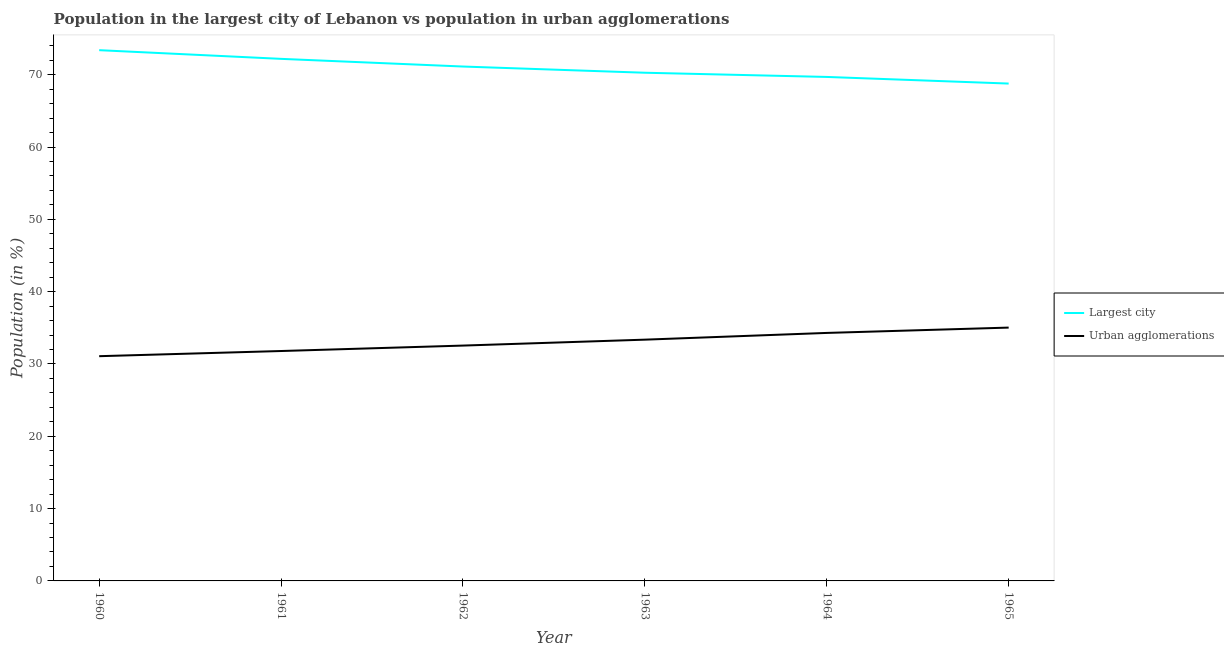Does the line corresponding to population in urban agglomerations intersect with the line corresponding to population in the largest city?
Keep it short and to the point. No. What is the population in urban agglomerations in 1964?
Provide a succinct answer. 34.29. Across all years, what is the maximum population in urban agglomerations?
Ensure brevity in your answer.  35.03. Across all years, what is the minimum population in the largest city?
Provide a succinct answer. 68.77. In which year was the population in urban agglomerations maximum?
Your answer should be very brief. 1965. In which year was the population in urban agglomerations minimum?
Your answer should be very brief. 1960. What is the total population in the largest city in the graph?
Offer a terse response. 425.45. What is the difference between the population in urban agglomerations in 1961 and that in 1965?
Provide a short and direct response. -3.24. What is the difference between the population in the largest city in 1964 and the population in urban agglomerations in 1962?
Provide a succinct answer. 37.15. What is the average population in the largest city per year?
Make the answer very short. 70.91. In the year 1965, what is the difference between the population in urban agglomerations and population in the largest city?
Offer a very short reply. -33.74. In how many years, is the population in urban agglomerations greater than 50 %?
Ensure brevity in your answer.  0. What is the ratio of the population in the largest city in 1961 to that in 1962?
Give a very brief answer. 1.01. Is the population in urban agglomerations in 1961 less than that in 1962?
Offer a very short reply. Yes. Is the difference between the population in urban agglomerations in 1961 and 1962 greater than the difference between the population in the largest city in 1961 and 1962?
Provide a succinct answer. No. What is the difference between the highest and the second highest population in the largest city?
Your answer should be compact. 1.2. What is the difference between the highest and the lowest population in urban agglomerations?
Your answer should be compact. 3.95. In how many years, is the population in urban agglomerations greater than the average population in urban agglomerations taken over all years?
Make the answer very short. 3. Is the population in urban agglomerations strictly less than the population in the largest city over the years?
Give a very brief answer. Yes. What is the difference between two consecutive major ticks on the Y-axis?
Your answer should be very brief. 10. Does the graph contain any zero values?
Provide a short and direct response. No. Does the graph contain grids?
Your response must be concise. No. Where does the legend appear in the graph?
Offer a very short reply. Center right. How many legend labels are there?
Make the answer very short. 2. How are the legend labels stacked?
Make the answer very short. Vertical. What is the title of the graph?
Provide a short and direct response. Population in the largest city of Lebanon vs population in urban agglomerations. Does "Domestic Liabilities" appear as one of the legend labels in the graph?
Offer a very short reply. No. What is the label or title of the Y-axis?
Ensure brevity in your answer.  Population (in %). What is the Population (in %) in Largest city in 1960?
Make the answer very short. 73.39. What is the Population (in %) in Urban agglomerations in 1960?
Give a very brief answer. 31.08. What is the Population (in %) of Largest city in 1961?
Give a very brief answer. 72.19. What is the Population (in %) in Urban agglomerations in 1961?
Make the answer very short. 31.79. What is the Population (in %) of Largest city in 1962?
Your answer should be very brief. 71.13. What is the Population (in %) of Urban agglomerations in 1962?
Your answer should be very brief. 32.54. What is the Population (in %) of Largest city in 1963?
Your answer should be very brief. 70.27. What is the Population (in %) of Urban agglomerations in 1963?
Your answer should be very brief. 33.36. What is the Population (in %) in Largest city in 1964?
Make the answer very short. 69.69. What is the Population (in %) of Urban agglomerations in 1964?
Give a very brief answer. 34.29. What is the Population (in %) of Largest city in 1965?
Provide a succinct answer. 68.77. What is the Population (in %) in Urban agglomerations in 1965?
Keep it short and to the point. 35.03. Across all years, what is the maximum Population (in %) of Largest city?
Offer a very short reply. 73.39. Across all years, what is the maximum Population (in %) of Urban agglomerations?
Your answer should be very brief. 35.03. Across all years, what is the minimum Population (in %) in Largest city?
Give a very brief answer. 68.77. Across all years, what is the minimum Population (in %) of Urban agglomerations?
Make the answer very short. 31.08. What is the total Population (in %) of Largest city in the graph?
Ensure brevity in your answer.  425.45. What is the total Population (in %) of Urban agglomerations in the graph?
Provide a short and direct response. 198.1. What is the difference between the Population (in %) in Largest city in 1960 and that in 1961?
Ensure brevity in your answer.  1.2. What is the difference between the Population (in %) of Urban agglomerations in 1960 and that in 1961?
Ensure brevity in your answer.  -0.72. What is the difference between the Population (in %) in Largest city in 1960 and that in 1962?
Offer a terse response. 2.26. What is the difference between the Population (in %) of Urban agglomerations in 1960 and that in 1962?
Make the answer very short. -1.47. What is the difference between the Population (in %) in Largest city in 1960 and that in 1963?
Provide a short and direct response. 3.12. What is the difference between the Population (in %) of Urban agglomerations in 1960 and that in 1963?
Offer a terse response. -2.29. What is the difference between the Population (in %) of Largest city in 1960 and that in 1964?
Keep it short and to the point. 3.7. What is the difference between the Population (in %) of Urban agglomerations in 1960 and that in 1964?
Offer a very short reply. -3.22. What is the difference between the Population (in %) in Largest city in 1960 and that in 1965?
Offer a very short reply. 4.62. What is the difference between the Population (in %) of Urban agglomerations in 1960 and that in 1965?
Provide a short and direct response. -3.95. What is the difference between the Population (in %) of Largest city in 1961 and that in 1962?
Your answer should be compact. 1.06. What is the difference between the Population (in %) in Urban agglomerations in 1961 and that in 1962?
Make the answer very short. -0.75. What is the difference between the Population (in %) of Largest city in 1961 and that in 1963?
Provide a succinct answer. 1.92. What is the difference between the Population (in %) of Urban agglomerations in 1961 and that in 1963?
Ensure brevity in your answer.  -1.57. What is the difference between the Population (in %) in Largest city in 1961 and that in 1964?
Your answer should be compact. 2.5. What is the difference between the Population (in %) of Urban agglomerations in 1961 and that in 1964?
Ensure brevity in your answer.  -2.5. What is the difference between the Population (in %) of Largest city in 1961 and that in 1965?
Make the answer very short. 3.42. What is the difference between the Population (in %) of Urban agglomerations in 1961 and that in 1965?
Your answer should be very brief. -3.24. What is the difference between the Population (in %) in Largest city in 1962 and that in 1963?
Provide a short and direct response. 0.86. What is the difference between the Population (in %) of Urban agglomerations in 1962 and that in 1963?
Give a very brief answer. -0.82. What is the difference between the Population (in %) of Largest city in 1962 and that in 1964?
Keep it short and to the point. 1.44. What is the difference between the Population (in %) in Urban agglomerations in 1962 and that in 1964?
Your answer should be compact. -1.75. What is the difference between the Population (in %) in Largest city in 1962 and that in 1965?
Provide a short and direct response. 2.36. What is the difference between the Population (in %) in Urban agglomerations in 1962 and that in 1965?
Offer a terse response. -2.49. What is the difference between the Population (in %) of Largest city in 1963 and that in 1964?
Your response must be concise. 0.58. What is the difference between the Population (in %) of Urban agglomerations in 1963 and that in 1964?
Your answer should be compact. -0.93. What is the difference between the Population (in %) in Largest city in 1963 and that in 1965?
Your response must be concise. 1.5. What is the difference between the Population (in %) of Urban agglomerations in 1963 and that in 1965?
Provide a succinct answer. -1.67. What is the difference between the Population (in %) in Largest city in 1964 and that in 1965?
Provide a succinct answer. 0.92. What is the difference between the Population (in %) in Urban agglomerations in 1964 and that in 1965?
Offer a very short reply. -0.74. What is the difference between the Population (in %) of Largest city in 1960 and the Population (in %) of Urban agglomerations in 1961?
Make the answer very short. 41.6. What is the difference between the Population (in %) in Largest city in 1960 and the Population (in %) in Urban agglomerations in 1962?
Make the answer very short. 40.85. What is the difference between the Population (in %) of Largest city in 1960 and the Population (in %) of Urban agglomerations in 1963?
Provide a short and direct response. 40.03. What is the difference between the Population (in %) in Largest city in 1960 and the Population (in %) in Urban agglomerations in 1964?
Offer a terse response. 39.1. What is the difference between the Population (in %) of Largest city in 1960 and the Population (in %) of Urban agglomerations in 1965?
Provide a short and direct response. 38.36. What is the difference between the Population (in %) in Largest city in 1961 and the Population (in %) in Urban agglomerations in 1962?
Your answer should be compact. 39.65. What is the difference between the Population (in %) in Largest city in 1961 and the Population (in %) in Urban agglomerations in 1963?
Keep it short and to the point. 38.83. What is the difference between the Population (in %) in Largest city in 1961 and the Population (in %) in Urban agglomerations in 1964?
Provide a short and direct response. 37.9. What is the difference between the Population (in %) in Largest city in 1961 and the Population (in %) in Urban agglomerations in 1965?
Ensure brevity in your answer.  37.16. What is the difference between the Population (in %) in Largest city in 1962 and the Population (in %) in Urban agglomerations in 1963?
Your answer should be very brief. 37.77. What is the difference between the Population (in %) in Largest city in 1962 and the Population (in %) in Urban agglomerations in 1964?
Provide a succinct answer. 36.84. What is the difference between the Population (in %) of Largest city in 1962 and the Population (in %) of Urban agglomerations in 1965?
Your answer should be very brief. 36.1. What is the difference between the Population (in %) of Largest city in 1963 and the Population (in %) of Urban agglomerations in 1964?
Give a very brief answer. 35.98. What is the difference between the Population (in %) of Largest city in 1963 and the Population (in %) of Urban agglomerations in 1965?
Ensure brevity in your answer.  35.24. What is the difference between the Population (in %) in Largest city in 1964 and the Population (in %) in Urban agglomerations in 1965?
Keep it short and to the point. 34.66. What is the average Population (in %) of Largest city per year?
Your answer should be compact. 70.91. What is the average Population (in %) of Urban agglomerations per year?
Keep it short and to the point. 33.02. In the year 1960, what is the difference between the Population (in %) of Largest city and Population (in %) of Urban agglomerations?
Offer a terse response. 42.32. In the year 1961, what is the difference between the Population (in %) of Largest city and Population (in %) of Urban agglomerations?
Your response must be concise. 40.4. In the year 1962, what is the difference between the Population (in %) of Largest city and Population (in %) of Urban agglomerations?
Make the answer very short. 38.59. In the year 1963, what is the difference between the Population (in %) in Largest city and Population (in %) in Urban agglomerations?
Ensure brevity in your answer.  36.91. In the year 1964, what is the difference between the Population (in %) of Largest city and Population (in %) of Urban agglomerations?
Keep it short and to the point. 35.4. In the year 1965, what is the difference between the Population (in %) of Largest city and Population (in %) of Urban agglomerations?
Give a very brief answer. 33.74. What is the ratio of the Population (in %) of Largest city in 1960 to that in 1961?
Provide a short and direct response. 1.02. What is the ratio of the Population (in %) of Urban agglomerations in 1960 to that in 1961?
Ensure brevity in your answer.  0.98. What is the ratio of the Population (in %) of Largest city in 1960 to that in 1962?
Offer a terse response. 1.03. What is the ratio of the Population (in %) in Urban agglomerations in 1960 to that in 1962?
Offer a very short reply. 0.95. What is the ratio of the Population (in %) of Largest city in 1960 to that in 1963?
Make the answer very short. 1.04. What is the ratio of the Population (in %) of Urban agglomerations in 1960 to that in 1963?
Provide a succinct answer. 0.93. What is the ratio of the Population (in %) of Largest city in 1960 to that in 1964?
Provide a short and direct response. 1.05. What is the ratio of the Population (in %) in Urban agglomerations in 1960 to that in 1964?
Give a very brief answer. 0.91. What is the ratio of the Population (in %) of Largest city in 1960 to that in 1965?
Offer a very short reply. 1.07. What is the ratio of the Population (in %) in Urban agglomerations in 1960 to that in 1965?
Give a very brief answer. 0.89. What is the ratio of the Population (in %) in Largest city in 1961 to that in 1962?
Your answer should be very brief. 1.01. What is the ratio of the Population (in %) in Urban agglomerations in 1961 to that in 1962?
Make the answer very short. 0.98. What is the ratio of the Population (in %) in Largest city in 1961 to that in 1963?
Your answer should be compact. 1.03. What is the ratio of the Population (in %) in Urban agglomerations in 1961 to that in 1963?
Ensure brevity in your answer.  0.95. What is the ratio of the Population (in %) in Largest city in 1961 to that in 1964?
Offer a terse response. 1.04. What is the ratio of the Population (in %) of Urban agglomerations in 1961 to that in 1964?
Offer a terse response. 0.93. What is the ratio of the Population (in %) in Largest city in 1961 to that in 1965?
Keep it short and to the point. 1.05. What is the ratio of the Population (in %) in Urban agglomerations in 1961 to that in 1965?
Offer a very short reply. 0.91. What is the ratio of the Population (in %) of Largest city in 1962 to that in 1963?
Provide a succinct answer. 1.01. What is the ratio of the Population (in %) in Urban agglomerations in 1962 to that in 1963?
Ensure brevity in your answer.  0.98. What is the ratio of the Population (in %) in Largest city in 1962 to that in 1964?
Make the answer very short. 1.02. What is the ratio of the Population (in %) of Urban agglomerations in 1962 to that in 1964?
Offer a very short reply. 0.95. What is the ratio of the Population (in %) of Largest city in 1962 to that in 1965?
Provide a succinct answer. 1.03. What is the ratio of the Population (in %) in Urban agglomerations in 1962 to that in 1965?
Provide a short and direct response. 0.93. What is the ratio of the Population (in %) of Largest city in 1963 to that in 1964?
Your answer should be compact. 1.01. What is the ratio of the Population (in %) of Urban agglomerations in 1963 to that in 1964?
Make the answer very short. 0.97. What is the ratio of the Population (in %) of Largest city in 1963 to that in 1965?
Keep it short and to the point. 1.02. What is the ratio of the Population (in %) of Urban agglomerations in 1963 to that in 1965?
Keep it short and to the point. 0.95. What is the ratio of the Population (in %) of Largest city in 1964 to that in 1965?
Your response must be concise. 1.01. What is the ratio of the Population (in %) of Urban agglomerations in 1964 to that in 1965?
Ensure brevity in your answer.  0.98. What is the difference between the highest and the second highest Population (in %) in Largest city?
Your answer should be compact. 1.2. What is the difference between the highest and the second highest Population (in %) in Urban agglomerations?
Your answer should be compact. 0.74. What is the difference between the highest and the lowest Population (in %) in Largest city?
Make the answer very short. 4.62. What is the difference between the highest and the lowest Population (in %) in Urban agglomerations?
Keep it short and to the point. 3.95. 